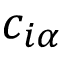<formula> <loc_0><loc_0><loc_500><loc_500>c _ { i \alpha }</formula> 